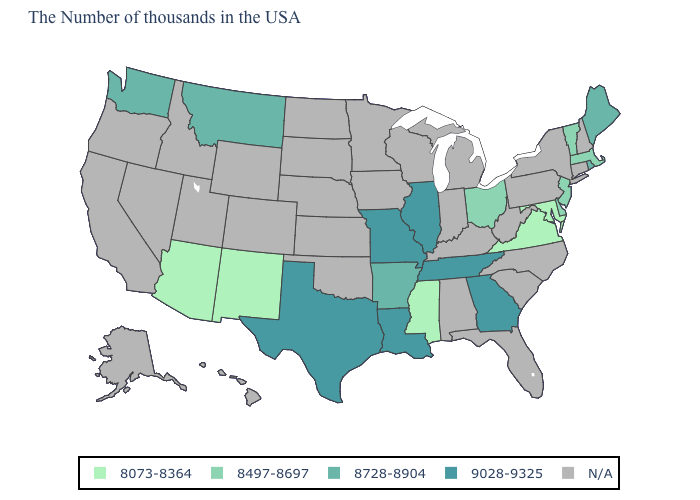What is the value of Arkansas?
Quick response, please. 8728-8904. Among the states that border Iowa , which have the highest value?
Keep it brief. Illinois, Missouri. What is the value of New Hampshire?
Keep it brief. N/A. Name the states that have a value in the range N/A?
Concise answer only. New Hampshire, Connecticut, New York, Pennsylvania, North Carolina, South Carolina, West Virginia, Florida, Michigan, Kentucky, Indiana, Alabama, Wisconsin, Minnesota, Iowa, Kansas, Nebraska, Oklahoma, South Dakota, North Dakota, Wyoming, Colorado, Utah, Idaho, Nevada, California, Oregon, Alaska, Hawaii. Name the states that have a value in the range 8728-8904?
Quick response, please. Maine, Rhode Island, Arkansas, Montana, Washington. Name the states that have a value in the range N/A?
Quick response, please. New Hampshire, Connecticut, New York, Pennsylvania, North Carolina, South Carolina, West Virginia, Florida, Michigan, Kentucky, Indiana, Alabama, Wisconsin, Minnesota, Iowa, Kansas, Nebraska, Oklahoma, South Dakota, North Dakota, Wyoming, Colorado, Utah, Idaho, Nevada, California, Oregon, Alaska, Hawaii. Is the legend a continuous bar?
Answer briefly. No. Name the states that have a value in the range 8073-8364?
Answer briefly. Maryland, Virginia, Mississippi, New Mexico, Arizona. Which states hav the highest value in the MidWest?
Be succinct. Illinois, Missouri. What is the value of New Mexico?
Write a very short answer. 8073-8364. What is the value of Georgia?
Answer briefly. 9028-9325. What is the value of Florida?
Keep it brief. N/A. What is the lowest value in the USA?
Give a very brief answer. 8073-8364. Which states hav the highest value in the South?
Give a very brief answer. Georgia, Tennessee, Louisiana, Texas. 